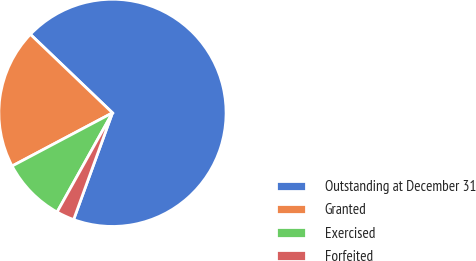Convert chart. <chart><loc_0><loc_0><loc_500><loc_500><pie_chart><fcel>Outstanding at December 31<fcel>Granted<fcel>Exercised<fcel>Forfeited<nl><fcel>68.41%<fcel>19.9%<fcel>9.14%<fcel>2.55%<nl></chart> 